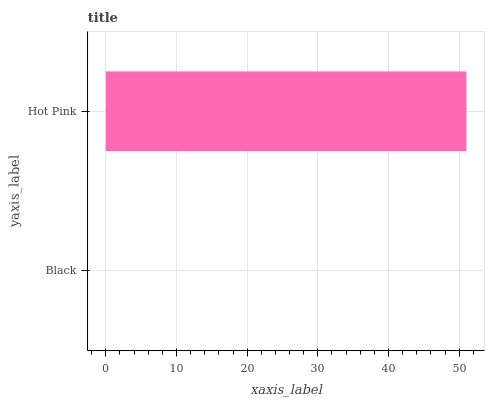Is Black the minimum?
Answer yes or no. Yes. Is Hot Pink the maximum?
Answer yes or no. Yes. Is Hot Pink the minimum?
Answer yes or no. No. Is Hot Pink greater than Black?
Answer yes or no. Yes. Is Black less than Hot Pink?
Answer yes or no. Yes. Is Black greater than Hot Pink?
Answer yes or no. No. Is Hot Pink less than Black?
Answer yes or no. No. Is Hot Pink the high median?
Answer yes or no. Yes. Is Black the low median?
Answer yes or no. Yes. Is Black the high median?
Answer yes or no. No. Is Hot Pink the low median?
Answer yes or no. No. 